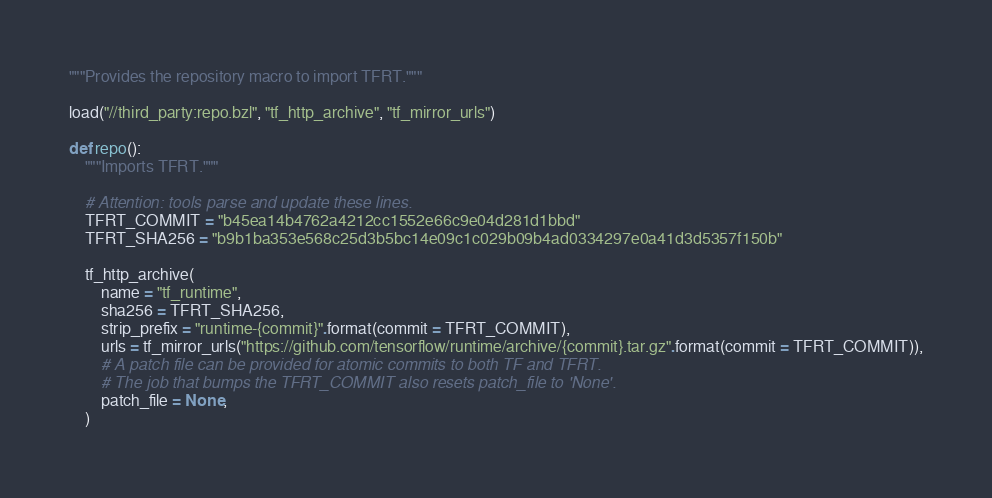Convert code to text. <code><loc_0><loc_0><loc_500><loc_500><_Python_>"""Provides the repository macro to import TFRT."""

load("//third_party:repo.bzl", "tf_http_archive", "tf_mirror_urls")

def repo():
    """Imports TFRT."""

    # Attention: tools parse and update these lines.
    TFRT_COMMIT = "b45ea14b4762a4212cc1552e66c9e04d281d1bbd"
    TFRT_SHA256 = "b9b1ba353e568c25d3b5bc14e09c1c029b09b4ad0334297e0a41d3d5357f150b"

    tf_http_archive(
        name = "tf_runtime",
        sha256 = TFRT_SHA256,
        strip_prefix = "runtime-{commit}".format(commit = TFRT_COMMIT),
        urls = tf_mirror_urls("https://github.com/tensorflow/runtime/archive/{commit}.tar.gz".format(commit = TFRT_COMMIT)),
        # A patch file can be provided for atomic commits to both TF and TFRT.
        # The job that bumps the TFRT_COMMIT also resets patch_file to 'None'.
        patch_file = None,
    )
</code> 